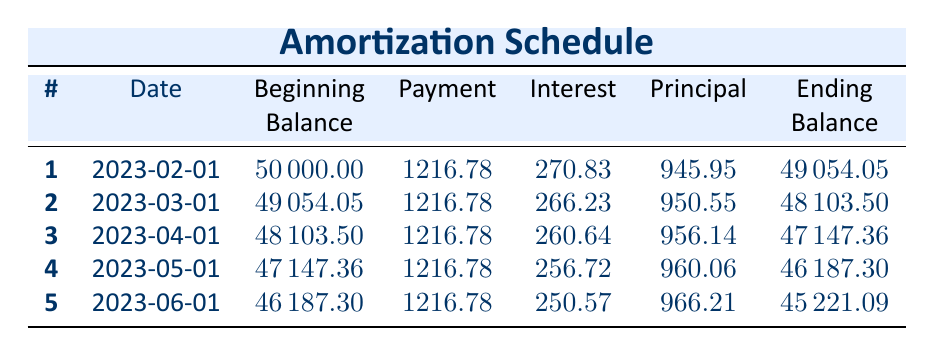What is the monthly payment amount for the loan? The monthly payment for the loan is provided in the table as 1216.78.
Answer: 1216.78 What is the beginning balance for the third payment? The beginning balance for the third payment is listed as 48103.50 in the table.
Answer: 48103.50 How much interest was paid in the second month? The interest paid in the second month is given as 266.23.
Answer: 266.23 What is the total principal paid after the first five payments? To find the total principal paid, we sum the principal amounts from the first five payments: 945.95 + 950.55 + 956.14 + 960.06 + 966.21 = 4879.91.
Answer: 4879.91 Is the outstanding balance decreasing with each payment? Yes, the ending balance after each payment is less than the previous beginning balance, indicating that it is decreasing.
Answer: Yes What was the ending balance after the fourth payment? The ending balance after the fourth payment is recorded as 46187.30 in the table.
Answer: 46187.30 What is the average interest paid over the five months? To find the average interest, we sum the interest amounts: 270.83 + 266.23 + 260.64 + 256.72 + 250.57 = 1305.09, and then divide by 5: 1305.09 / 5 = 261.018.
Answer: 261.02 How much was the principal paid in the first payment compared to the last payment? The principal paid in the first payment is 945.95 and in the last payment is 966.21. The principal was paid 966.21 - 945.95 = 20.26 more in the last payment.
Answer: 20.26 What is the total amount paid in interest over the first five payments? The total interest paid is calculated as the sum of all interest payments: 270.83 + 266.23 + 260.64 + 256.72 + 250.57 = 1305.09.
Answer: 1305.09 